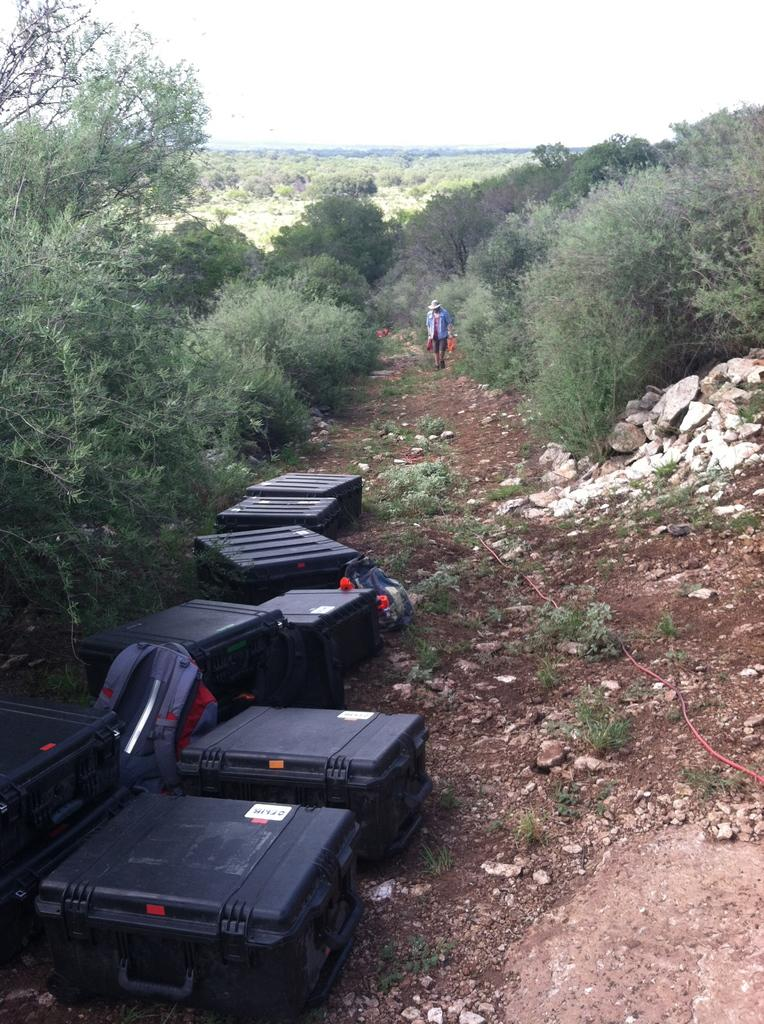What type of luggage can be seen in the image? There are suitcases and bags in the image. What type of natural environment is visible in the image? There are trees, grass, and stones in the image. Can you describe the person in the image? There is a person standing in the image. What color is the pickle that the person is holding in the image? There is no pickle present in the image. How many cubes can be seen stacked on the edge of the suitcase in the image? There are no cubes present in the image. 